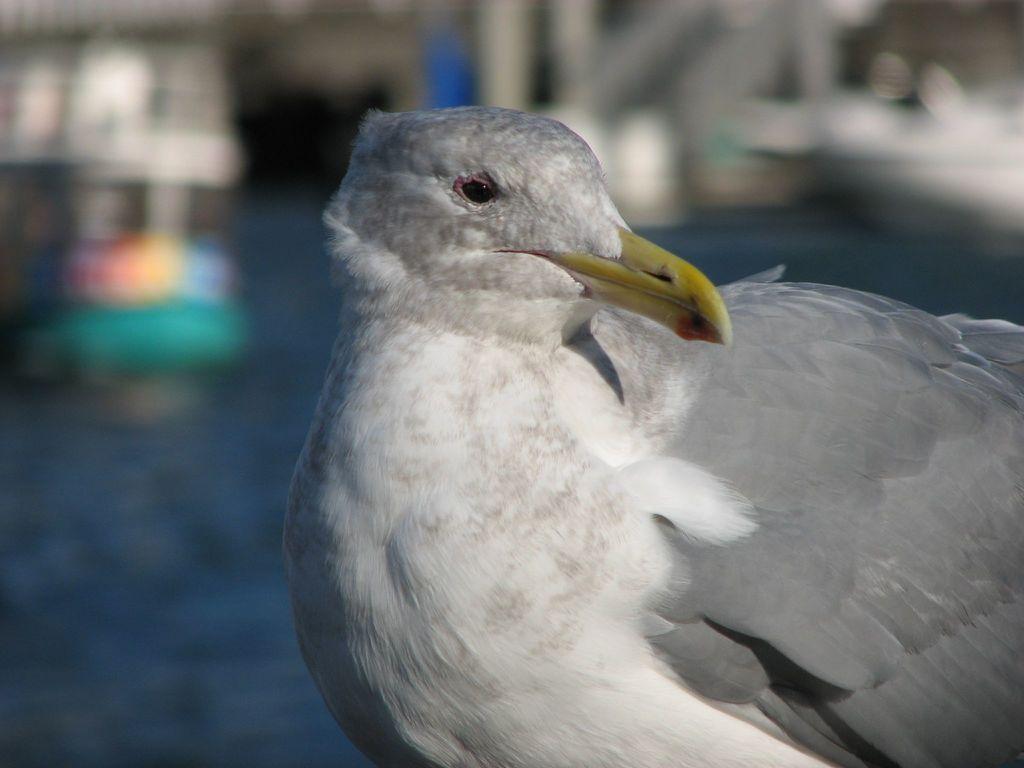Please provide a concise description of this image. In this image there is a pigeon in the middle. The colour of the pigeon is white. 